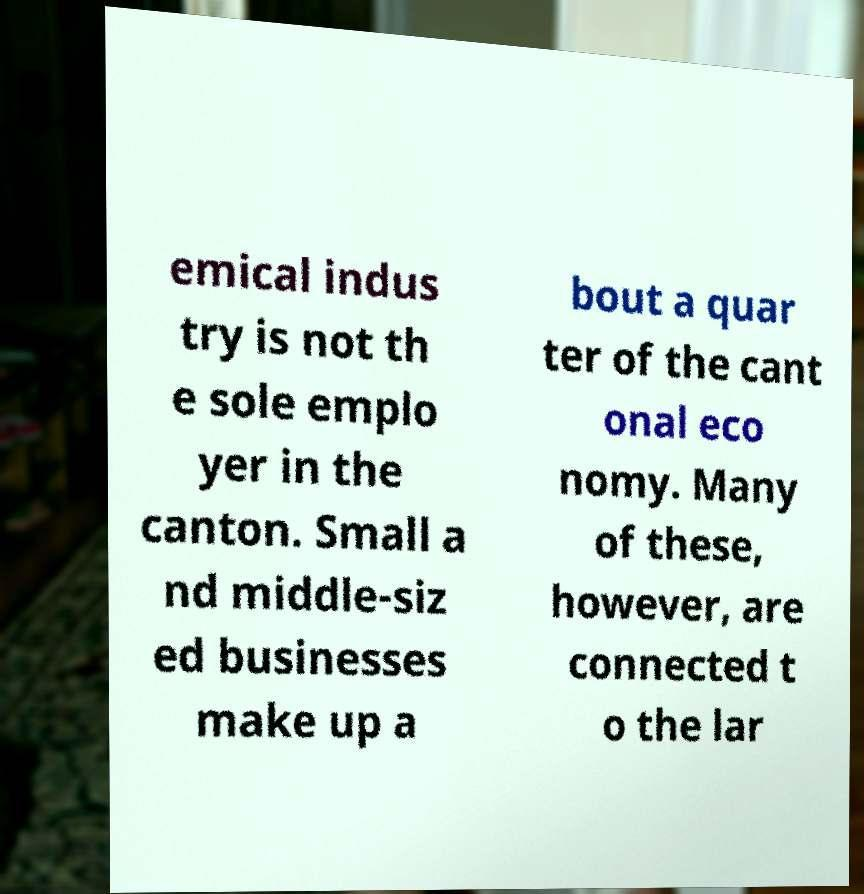Can you accurately transcribe the text from the provided image for me? emical indus try is not th e sole emplo yer in the canton. Small a nd middle-siz ed businesses make up a bout a quar ter of the cant onal eco nomy. Many of these, however, are connected t o the lar 